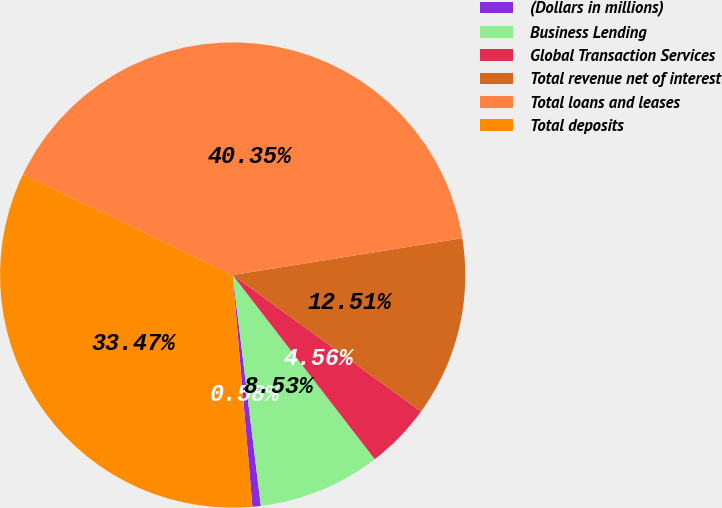<chart> <loc_0><loc_0><loc_500><loc_500><pie_chart><fcel>(Dollars in millions)<fcel>Business Lending<fcel>Global Transaction Services<fcel>Total revenue net of interest<fcel>Total loans and leases<fcel>Total deposits<nl><fcel>0.58%<fcel>8.53%<fcel>4.56%<fcel>12.51%<fcel>40.35%<fcel>33.47%<nl></chart> 